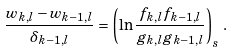<formula> <loc_0><loc_0><loc_500><loc_500>\frac { w _ { k , l } - w _ { k - 1 , l } } { \delta _ { k - 1 , l } } = \left ( \ln \frac { f _ { k , l } f _ { k - 1 , l } } { { g } _ { k , l } { g } _ { k - 1 , l } } \right ) _ { s } \, .</formula> 